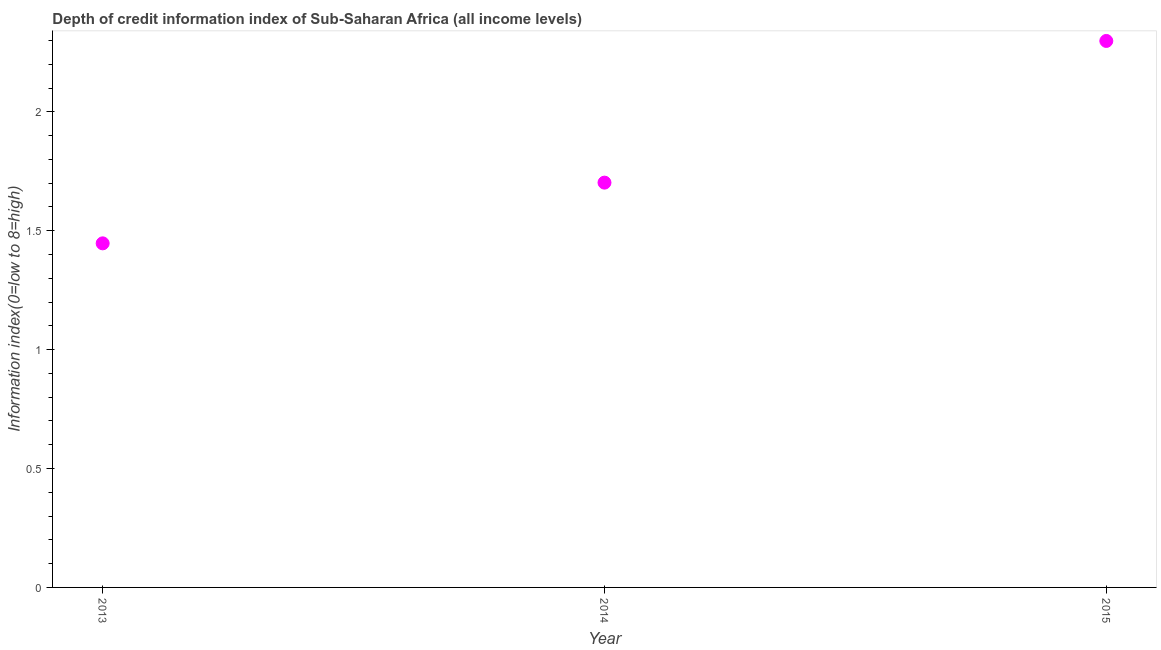What is the depth of credit information index in 2013?
Make the answer very short. 1.45. Across all years, what is the maximum depth of credit information index?
Keep it short and to the point. 2.3. Across all years, what is the minimum depth of credit information index?
Your answer should be very brief. 1.45. In which year was the depth of credit information index maximum?
Your answer should be very brief. 2015. What is the sum of the depth of credit information index?
Provide a succinct answer. 5.45. What is the difference between the depth of credit information index in 2013 and 2015?
Your answer should be very brief. -0.85. What is the average depth of credit information index per year?
Your response must be concise. 1.82. What is the median depth of credit information index?
Your answer should be very brief. 1.7. In how many years, is the depth of credit information index greater than 1.3 ?
Your answer should be compact. 3. Do a majority of the years between 2015 and 2014 (inclusive) have depth of credit information index greater than 1.4 ?
Keep it short and to the point. No. What is the ratio of the depth of credit information index in 2014 to that in 2015?
Offer a terse response. 0.74. What is the difference between the highest and the second highest depth of credit information index?
Offer a terse response. 0.6. What is the difference between the highest and the lowest depth of credit information index?
Keep it short and to the point. 0.85. In how many years, is the depth of credit information index greater than the average depth of credit information index taken over all years?
Make the answer very short. 1. Does the depth of credit information index monotonically increase over the years?
Offer a very short reply. Yes. How many years are there in the graph?
Make the answer very short. 3. Does the graph contain any zero values?
Your answer should be compact. No. What is the title of the graph?
Ensure brevity in your answer.  Depth of credit information index of Sub-Saharan Africa (all income levels). What is the label or title of the X-axis?
Provide a short and direct response. Year. What is the label or title of the Y-axis?
Provide a short and direct response. Information index(0=low to 8=high). What is the Information index(0=low to 8=high) in 2013?
Ensure brevity in your answer.  1.45. What is the Information index(0=low to 8=high) in 2014?
Make the answer very short. 1.7. What is the Information index(0=low to 8=high) in 2015?
Your answer should be very brief. 2.3. What is the difference between the Information index(0=low to 8=high) in 2013 and 2014?
Keep it short and to the point. -0.26. What is the difference between the Information index(0=low to 8=high) in 2013 and 2015?
Your response must be concise. -0.85. What is the difference between the Information index(0=low to 8=high) in 2014 and 2015?
Your response must be concise. -0.6. What is the ratio of the Information index(0=low to 8=high) in 2013 to that in 2015?
Give a very brief answer. 0.63. What is the ratio of the Information index(0=low to 8=high) in 2014 to that in 2015?
Your answer should be compact. 0.74. 